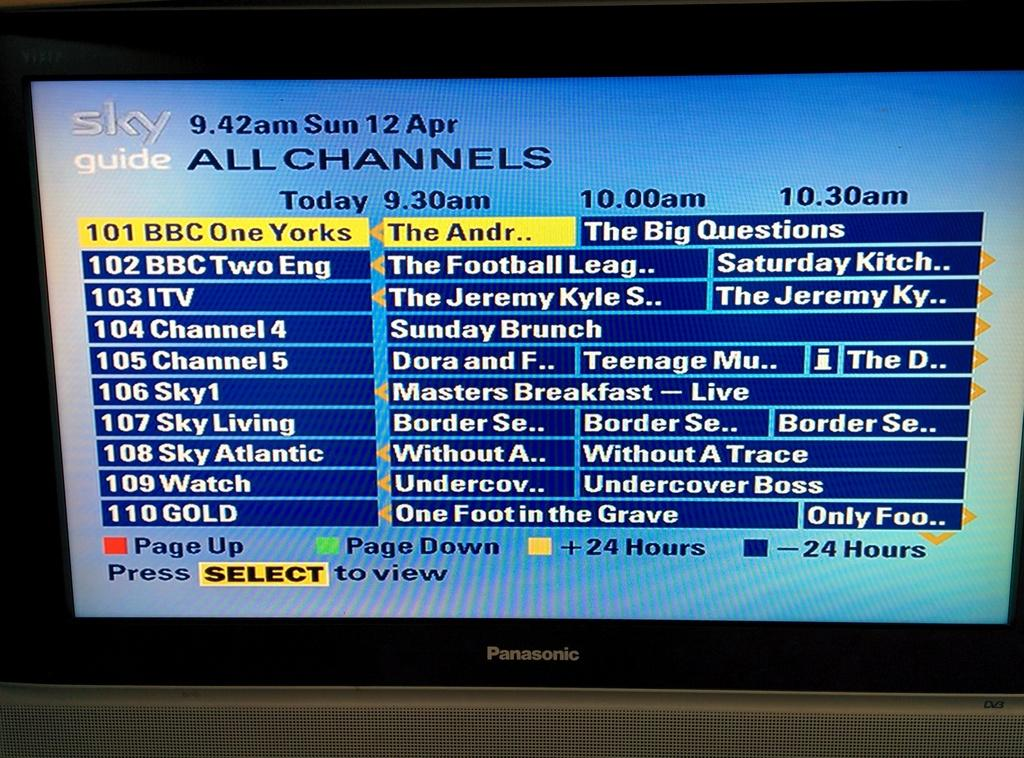<image>
Summarize the visual content of the image. a tv guide for sunday april 12 in white writing on a blue background 